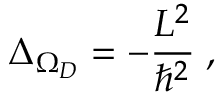<formula> <loc_0><loc_0><loc_500><loc_500>\Delta _ { \Omega _ { D } } = - \frac { L ^ { 2 } } { \hbar { ^ } { 2 } } \, ,</formula> 